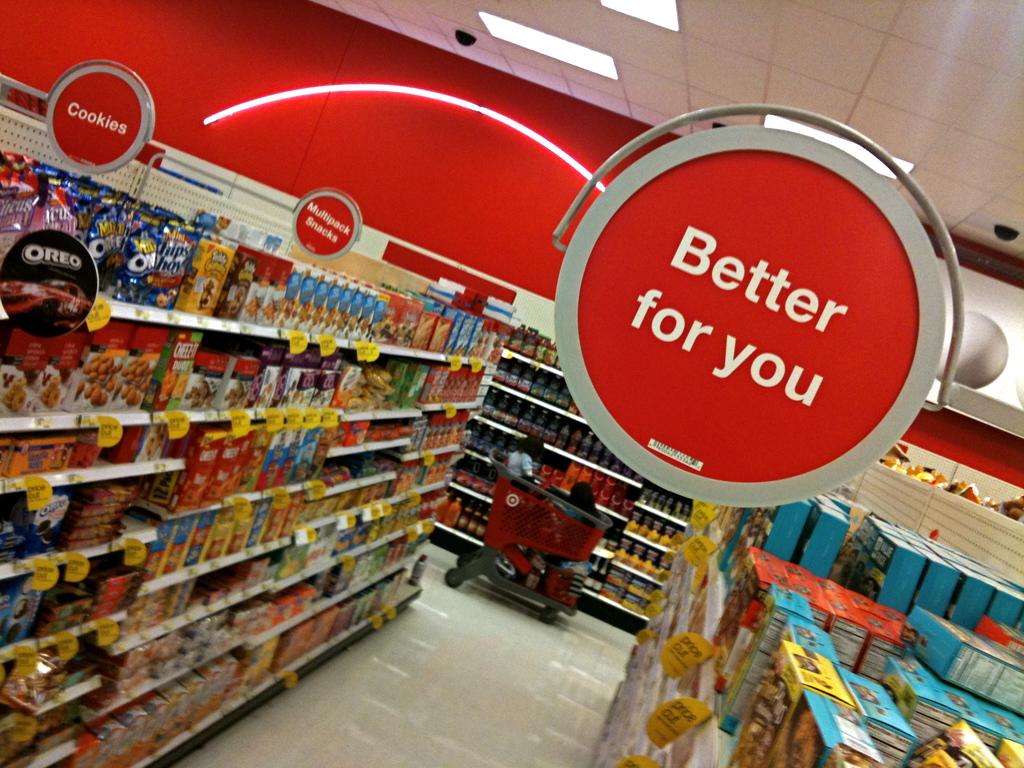Is the food in this isle bad for you?
Provide a short and direct response. No. 